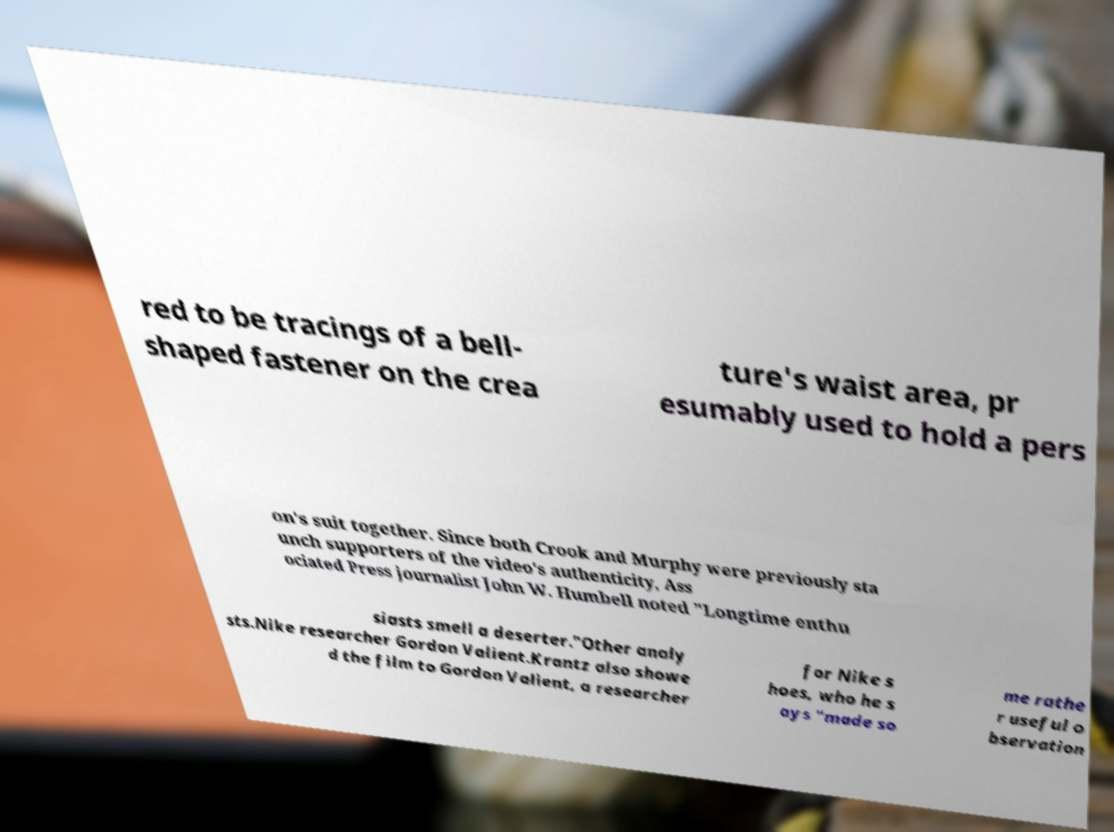Can you read and provide the text displayed in the image?This photo seems to have some interesting text. Can you extract and type it out for me? red to be tracings of a bell- shaped fastener on the crea ture's waist area, pr esumably used to hold a pers on's suit together. Since both Crook and Murphy were previously sta unch supporters of the video's authenticity, Ass ociated Press journalist John W. Humbell noted "Longtime enthu siasts smell a deserter."Other analy sts.Nike researcher Gordon Valient.Krantz also showe d the film to Gordon Valient, a researcher for Nike s hoes, who he s ays "made so me rathe r useful o bservation 